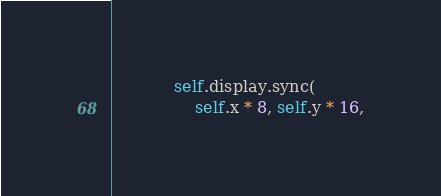Convert code to text. <code><loc_0><loc_0><loc_500><loc_500><_Rust_>
            self.display.sync(
                self.x * 8, self.y * 16,</code> 